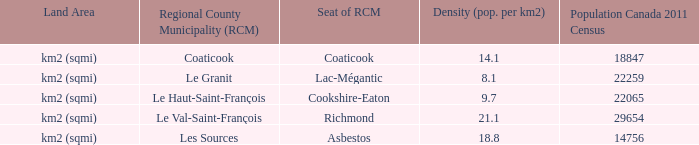What is the land area for the RCM that has a population of 18847? Km2 (sqmi). 